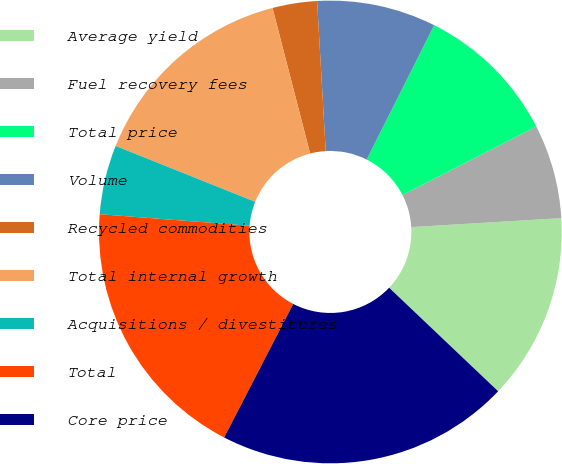<chart> <loc_0><loc_0><loc_500><loc_500><pie_chart><fcel>Average yield<fcel>Fuel recovery fees<fcel>Total price<fcel>Volume<fcel>Recycled commodities<fcel>Total internal growth<fcel>Acquisitions / divestitures<fcel>Total<fcel>Core price<nl><fcel>13.04%<fcel>6.58%<fcel>10.06%<fcel>8.32%<fcel>3.11%<fcel>14.91%<fcel>4.84%<fcel>18.63%<fcel>20.5%<nl></chart> 